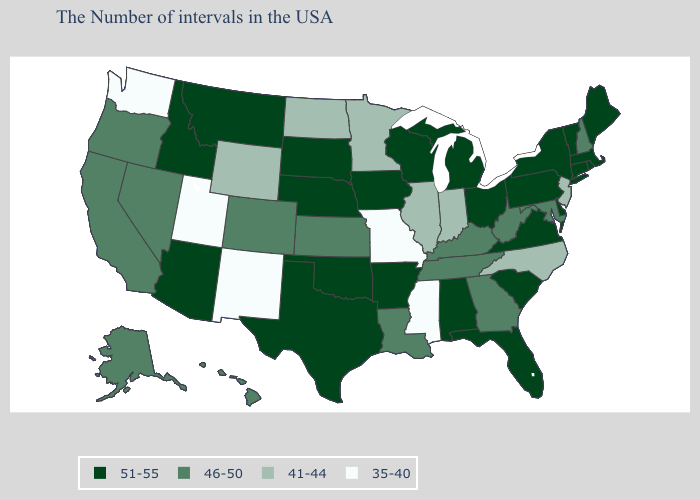Does the map have missing data?
Concise answer only. No. What is the highest value in states that border Kentucky?
Short answer required. 51-55. What is the value of West Virginia?
Quick response, please. 46-50. Does Oklahoma have a higher value than California?
Give a very brief answer. Yes. Does the map have missing data?
Give a very brief answer. No. What is the value of Ohio?
Give a very brief answer. 51-55. Name the states that have a value in the range 46-50?
Concise answer only. New Hampshire, Maryland, West Virginia, Georgia, Kentucky, Tennessee, Louisiana, Kansas, Colorado, Nevada, California, Oregon, Alaska, Hawaii. What is the value of Wisconsin?
Answer briefly. 51-55. Does Alaska have the same value as Kentucky?
Give a very brief answer. Yes. What is the highest value in the South ?
Write a very short answer. 51-55. What is the value of Mississippi?
Write a very short answer. 35-40. Name the states that have a value in the range 35-40?
Short answer required. Mississippi, Missouri, New Mexico, Utah, Washington. What is the value of Hawaii?
Write a very short answer. 46-50. Among the states that border Montana , which have the highest value?
Concise answer only. South Dakota, Idaho. 